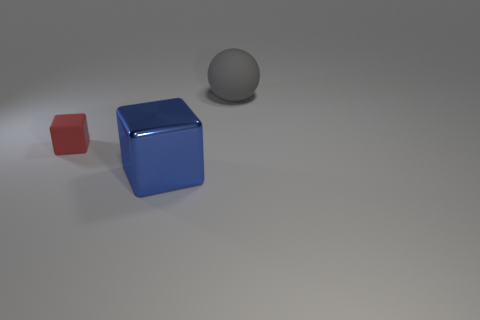Does the gray sphere have the same size as the cube that is in front of the small red cube?
Provide a succinct answer. Yes. What size is the metallic object that is the same shape as the tiny red matte object?
Ensure brevity in your answer.  Large. There is a big object that is on the right side of the large object that is in front of the matte ball; what number of things are in front of it?
Make the answer very short. 2. How many spheres are either large brown objects or tiny rubber objects?
Your answer should be compact. 0. The cube that is right of the rubber object left of the big matte object that is behind the small red matte block is what color?
Your answer should be very brief. Blue. What number of other objects are there of the same size as the rubber cube?
Provide a succinct answer. 0. Is there anything else that is the same shape as the big gray matte thing?
Your answer should be very brief. No. There is a large metal object that is the same shape as the small red matte object; what is its color?
Your answer should be compact. Blue. The big sphere that is the same material as the tiny cube is what color?
Your answer should be compact. Gray. Are there the same number of large blue things left of the large metallic block and large purple metal blocks?
Your answer should be very brief. Yes. 